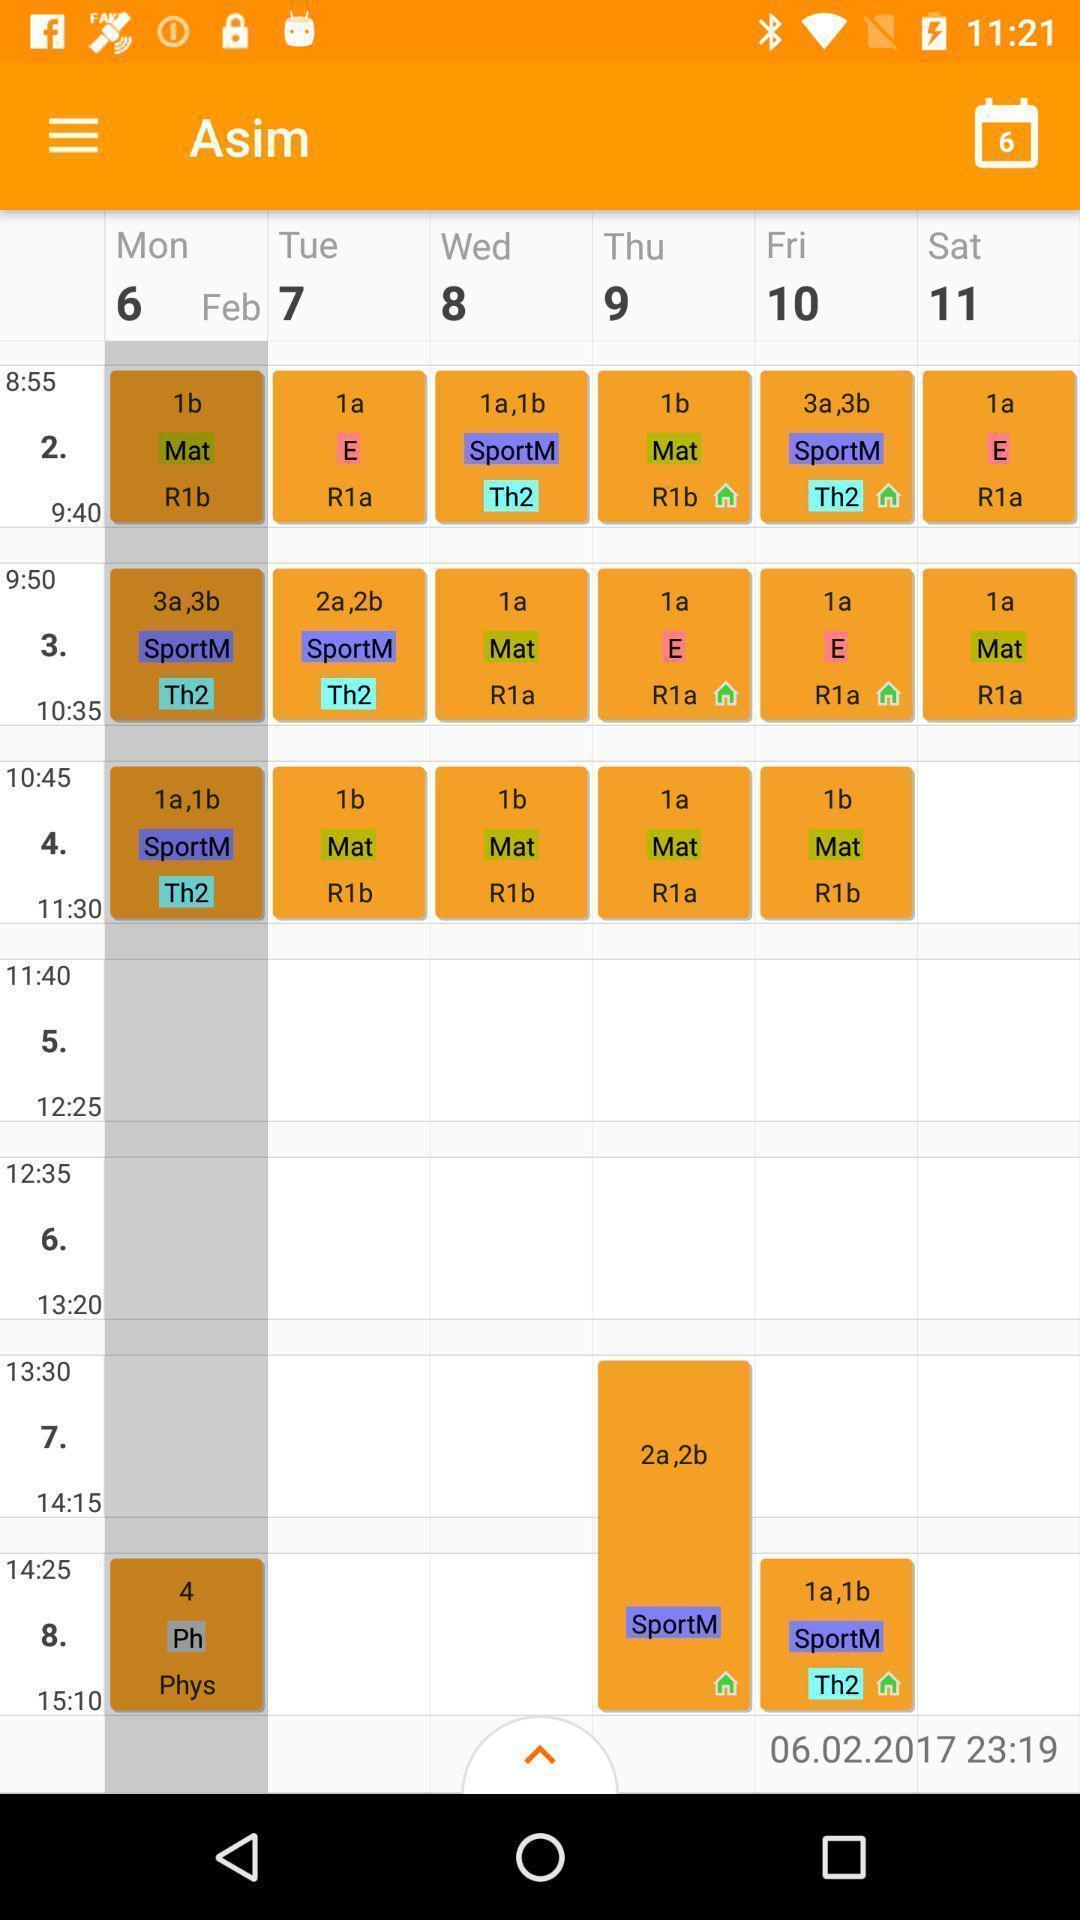Explain the elements present in this screenshot. Page showing time table with date. 